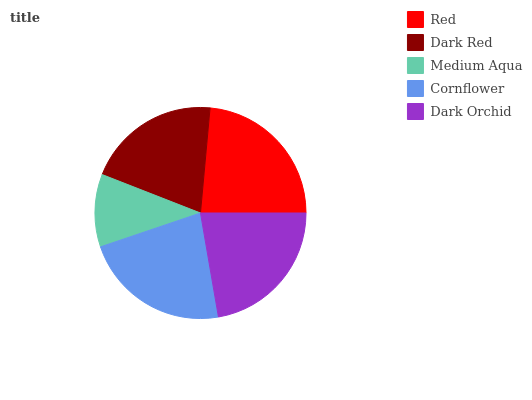Is Medium Aqua the minimum?
Answer yes or no. Yes. Is Red the maximum?
Answer yes or no. Yes. Is Dark Red the minimum?
Answer yes or no. No. Is Dark Red the maximum?
Answer yes or no. No. Is Red greater than Dark Red?
Answer yes or no. Yes. Is Dark Red less than Red?
Answer yes or no. Yes. Is Dark Red greater than Red?
Answer yes or no. No. Is Red less than Dark Red?
Answer yes or no. No. Is Dark Orchid the high median?
Answer yes or no. Yes. Is Dark Orchid the low median?
Answer yes or no. Yes. Is Red the high median?
Answer yes or no. No. Is Dark Red the low median?
Answer yes or no. No. 